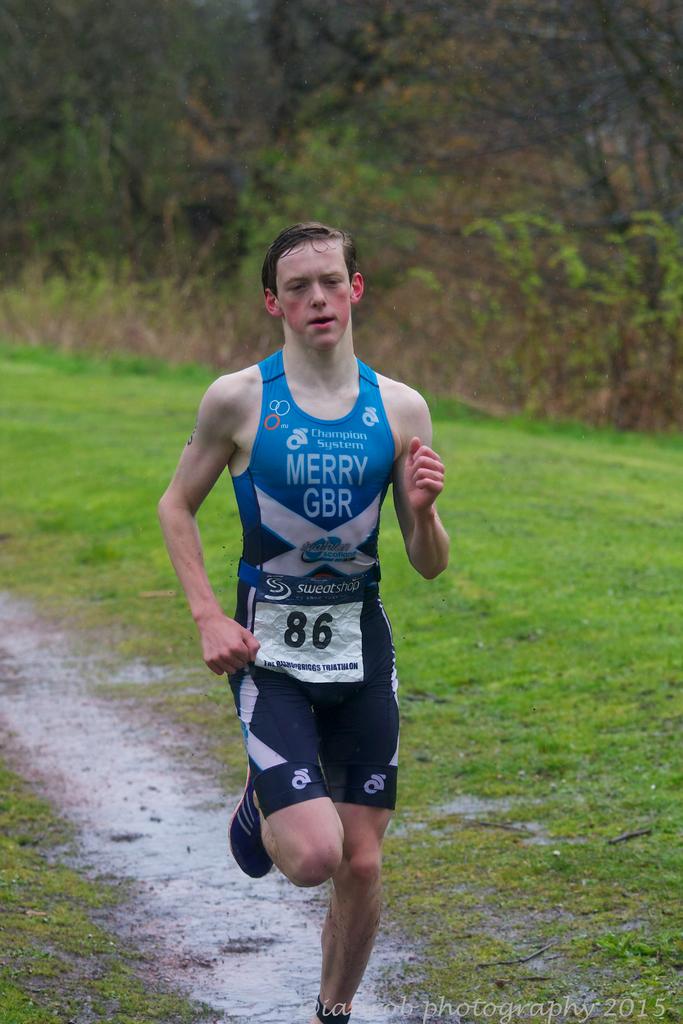What number is this runner?
Your response must be concise. 86. Where is the runner representing?
Provide a succinct answer. Merry gbr. 